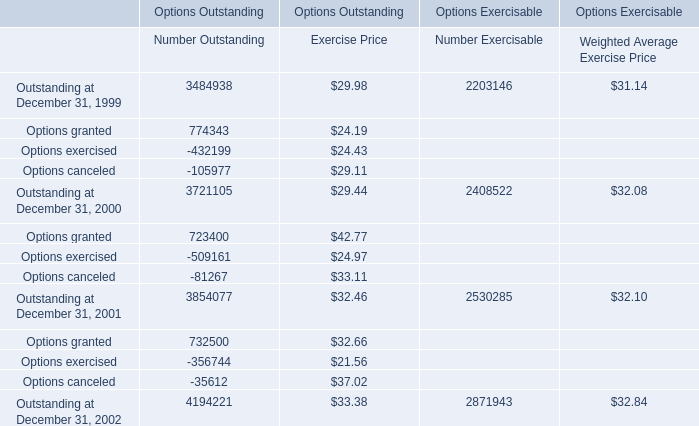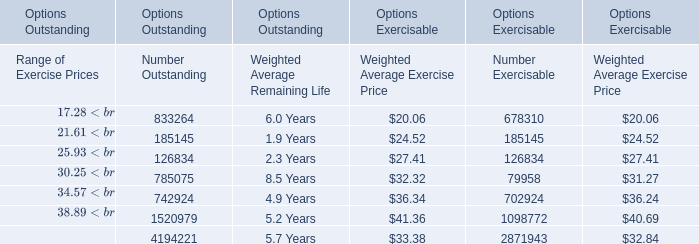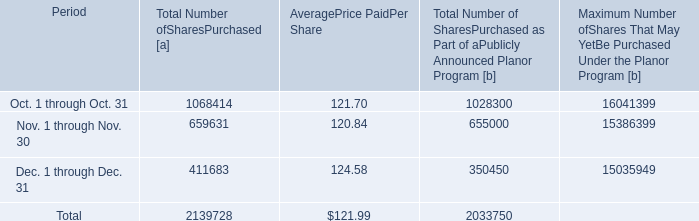what portion of the 2011 plan repurchases were repurchased in 2012? 
Computations: (13804709 / (40 * 1000000))
Answer: 0.34512. 